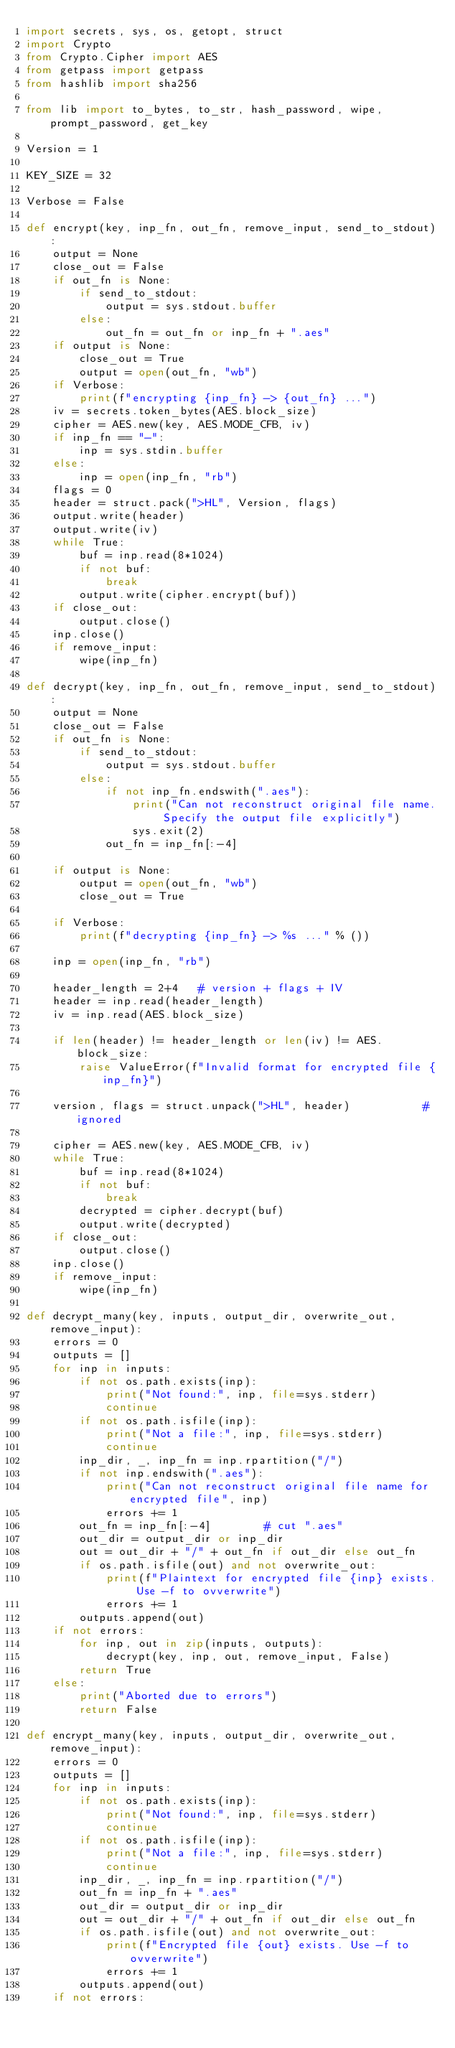<code> <loc_0><loc_0><loc_500><loc_500><_Python_>import secrets, sys, os, getopt, struct
import Crypto
from Crypto.Cipher import AES
from getpass import getpass
from hashlib import sha256

from lib import to_bytes, to_str, hash_password, wipe, prompt_password, get_key

Version = 1

KEY_SIZE = 32

Verbose = False

def encrypt(key, inp_fn, out_fn, remove_input, send_to_stdout):
    output = None
    close_out = False
    if out_fn is None:
        if send_to_stdout:
            output = sys.stdout.buffer
        else:
            out_fn = out_fn or inp_fn + ".aes"
    if output is None:  
        close_out = True
        output = open(out_fn, "wb")
    if Verbose:
        print(f"encrypting {inp_fn} -> {out_fn} ...")
    iv = secrets.token_bytes(AES.block_size)
    cipher = AES.new(key, AES.MODE_CFB, iv)
    if inp_fn == "-":
        inp = sys.stdin.buffer
    else:
        inp = open(inp_fn, "rb")
    flags = 0    
    header = struct.pack(">HL", Version, flags)
    output.write(header)
    output.write(iv)
    while True:
        buf = inp.read(8*1024)
        if not buf:
            break
        output.write(cipher.encrypt(buf))
    if close_out:
        output.close()
    inp.close()
    if remove_input:
        wipe(inp_fn)
    
def decrypt(key, inp_fn, out_fn, remove_input, send_to_stdout):
    output = None
    close_out = False
    if out_fn is None:
        if send_to_stdout:
            output = sys.stdout.buffer
        else:
            if not inp_fn.endswith(".aes"):
                print("Can not reconstruct original file name. Specify the output file explicitly")
                sys.exit(2)
            out_fn = inp_fn[:-4]

    if output is None:
        output = open(out_fn, "wb")
        close_out = True

    if Verbose:
        print(f"decrypting {inp_fn} -> %s ..." % ())

    inp = open(inp_fn, "rb")

    header_length = 2+4   # version + flags + IV
    header = inp.read(header_length)
    iv = inp.read(AES.block_size)

    if len(header) != header_length or len(iv) != AES.block_size:
        raise ValueError(f"Invalid format for encrypted file {inp_fn}")

    version, flags = struct.unpack(">HL", header)           # ignored
        
    cipher = AES.new(key, AES.MODE_CFB, iv)
    while True:
        buf = inp.read(8*1024)
        if not buf:
            break
        decrypted = cipher.decrypt(buf)
        output.write(decrypted)
    if close_out:
        output.close()
    inp.close()
    if remove_input:
        wipe(inp_fn)

def decrypt_many(key, inputs, output_dir, overwrite_out, remove_input):
    errors = 0
    outputs = []
    for inp in inputs:
        if not os.path.exists(inp):
            print("Not found:", inp, file=sys.stderr)
            continue
        if not os.path.isfile(inp):
            print("Not a file:", inp, file=sys.stderr)
            continue            
        inp_dir, _, inp_fn = inp.rpartition("/")
        if not inp.endswith(".aes"):
            print("Can not reconstruct original file name for encrypted file", inp)
            errors += 1
        out_fn = inp_fn[:-4]        # cut ".aes"
        out_dir = output_dir or inp_dir
        out = out_dir + "/" + out_fn if out_dir else out_fn
        if os.path.isfile(out) and not overwrite_out:
            print(f"Plaintext for encrypted file {inp} exists. Use -f to ovverwrite")
            errors += 1
        outputs.append(out)
    if not errors:
        for inp, out in zip(inputs, outputs):
            decrypt(key, inp, out, remove_input, False)
        return True
    else:
        print("Aborted due to errors")
        return False

def encrypt_many(key, inputs, output_dir, overwrite_out, remove_input):
    errors = 0
    outputs = []
    for inp in inputs:
        if not os.path.exists(inp):
            print("Not found:", inp, file=sys.stderr)
            continue
        if not os.path.isfile(inp):
            print("Not a file:", inp, file=sys.stderr)
            continue            
        inp_dir, _, inp_fn = inp.rpartition("/")
        out_fn = inp_fn + ".aes"
        out_dir = output_dir or inp_dir
        out = out_dir + "/" + out_fn if out_dir else out_fn
        if os.path.isfile(out) and not overwrite_out:
            print(f"Encrypted file {out} exists. Use -f to ovverwrite")
            errors += 1
        outputs.append(out)
    if not errors:</code> 